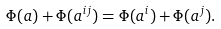Convert formula to latex. <formula><loc_0><loc_0><loc_500><loc_500>\Phi ( a ) + \Phi ( a ^ { i j } ) = \Phi ( a ^ { i } ) + \Phi ( a ^ { j } ) .</formula> 